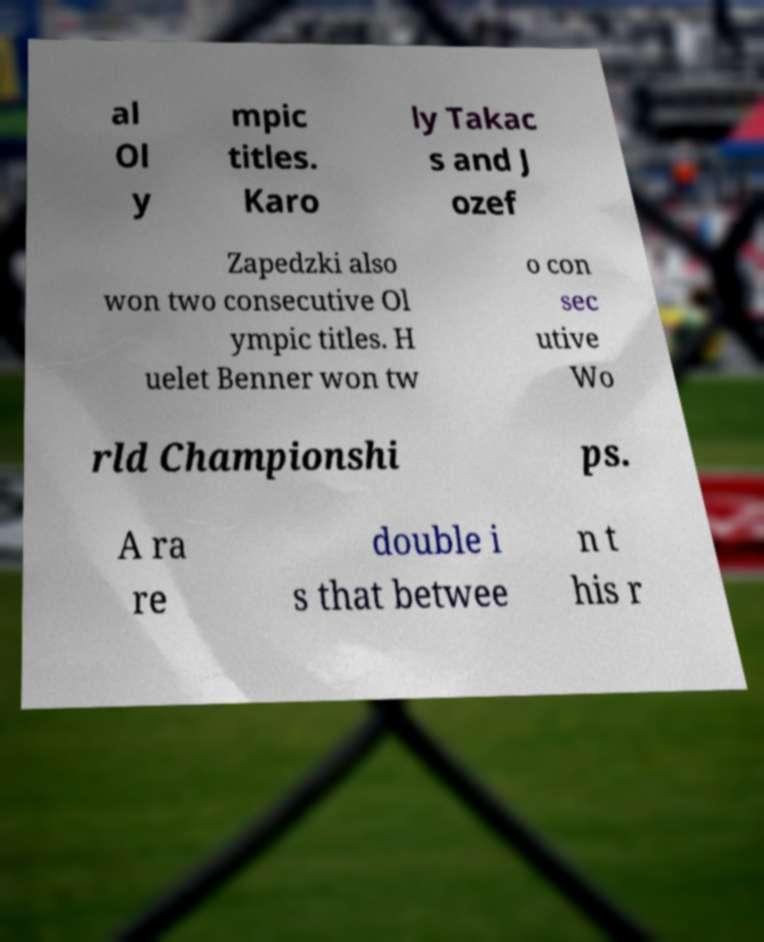Please read and relay the text visible in this image. What does it say? al Ol y mpic titles. Karo ly Takac s and J ozef Zapedzki also won two consecutive Ol ympic titles. H uelet Benner won tw o con sec utive Wo rld Championshi ps. A ra re double i s that betwee n t his r 